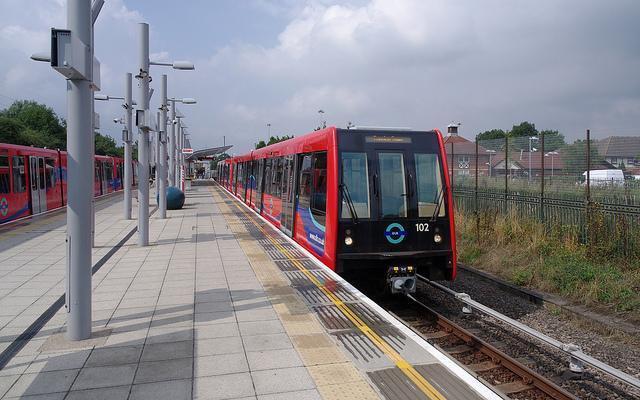How many people are waiting on the platform?
Give a very brief answer. 0. How many trains are visible?
Give a very brief answer. 2. 